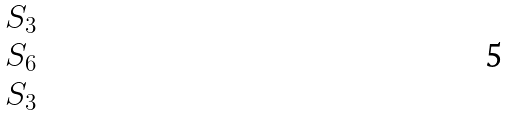<formula> <loc_0><loc_0><loc_500><loc_500>\begin{matrix} S _ { 3 } \\ S _ { 6 } \\ S _ { 3 } \end{matrix}</formula> 